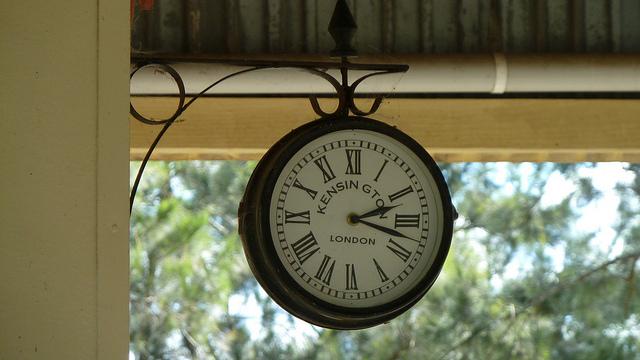What type of numerals are on the clock face?
Be succinct. Roman. Is this clock on a wall?
Concise answer only. No. What time does the clock say?
Short answer required. 2:18. 